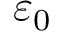Convert formula to latex. <formula><loc_0><loc_0><loc_500><loc_500>\varepsilon _ { 0 }</formula> 